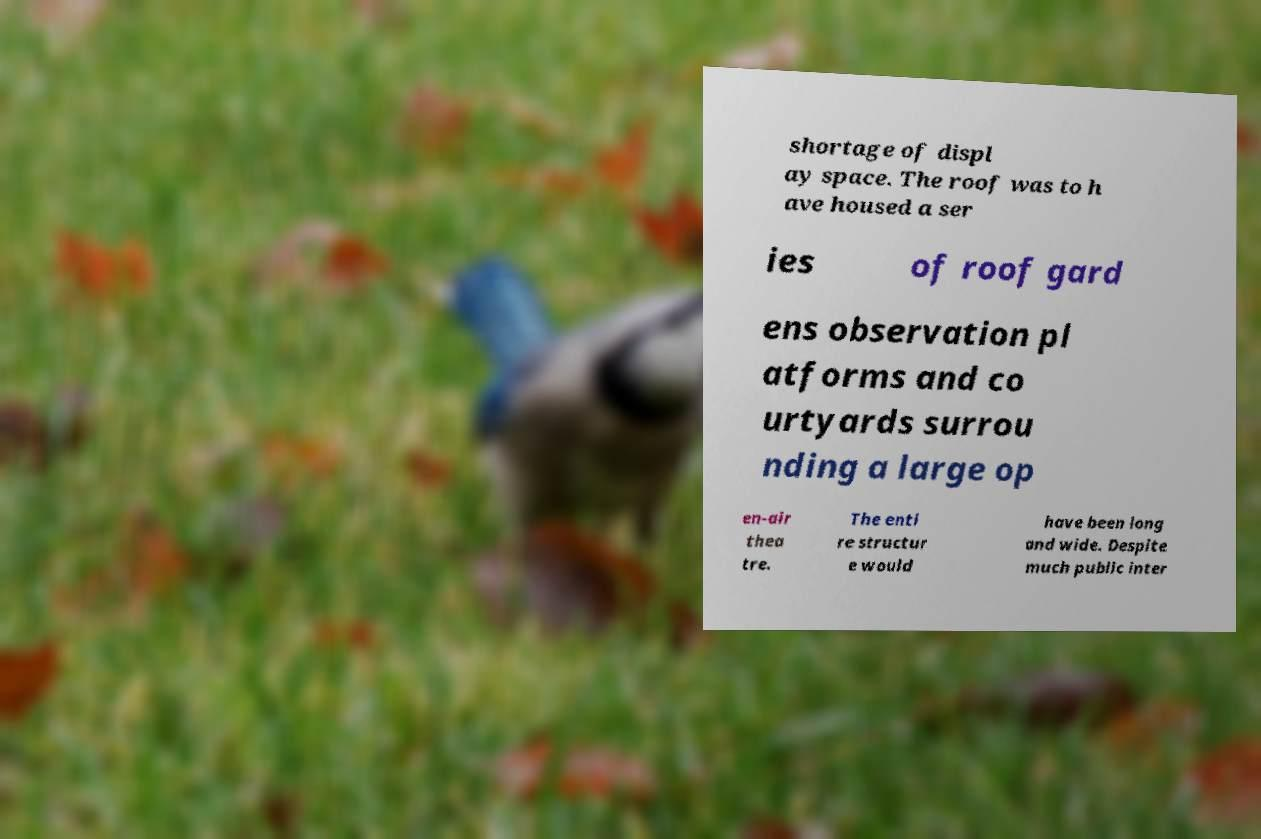There's text embedded in this image that I need extracted. Can you transcribe it verbatim? shortage of displ ay space. The roof was to h ave housed a ser ies of roof gard ens observation pl atforms and co urtyards surrou nding a large op en-air thea tre. The enti re structur e would have been long and wide. Despite much public inter 